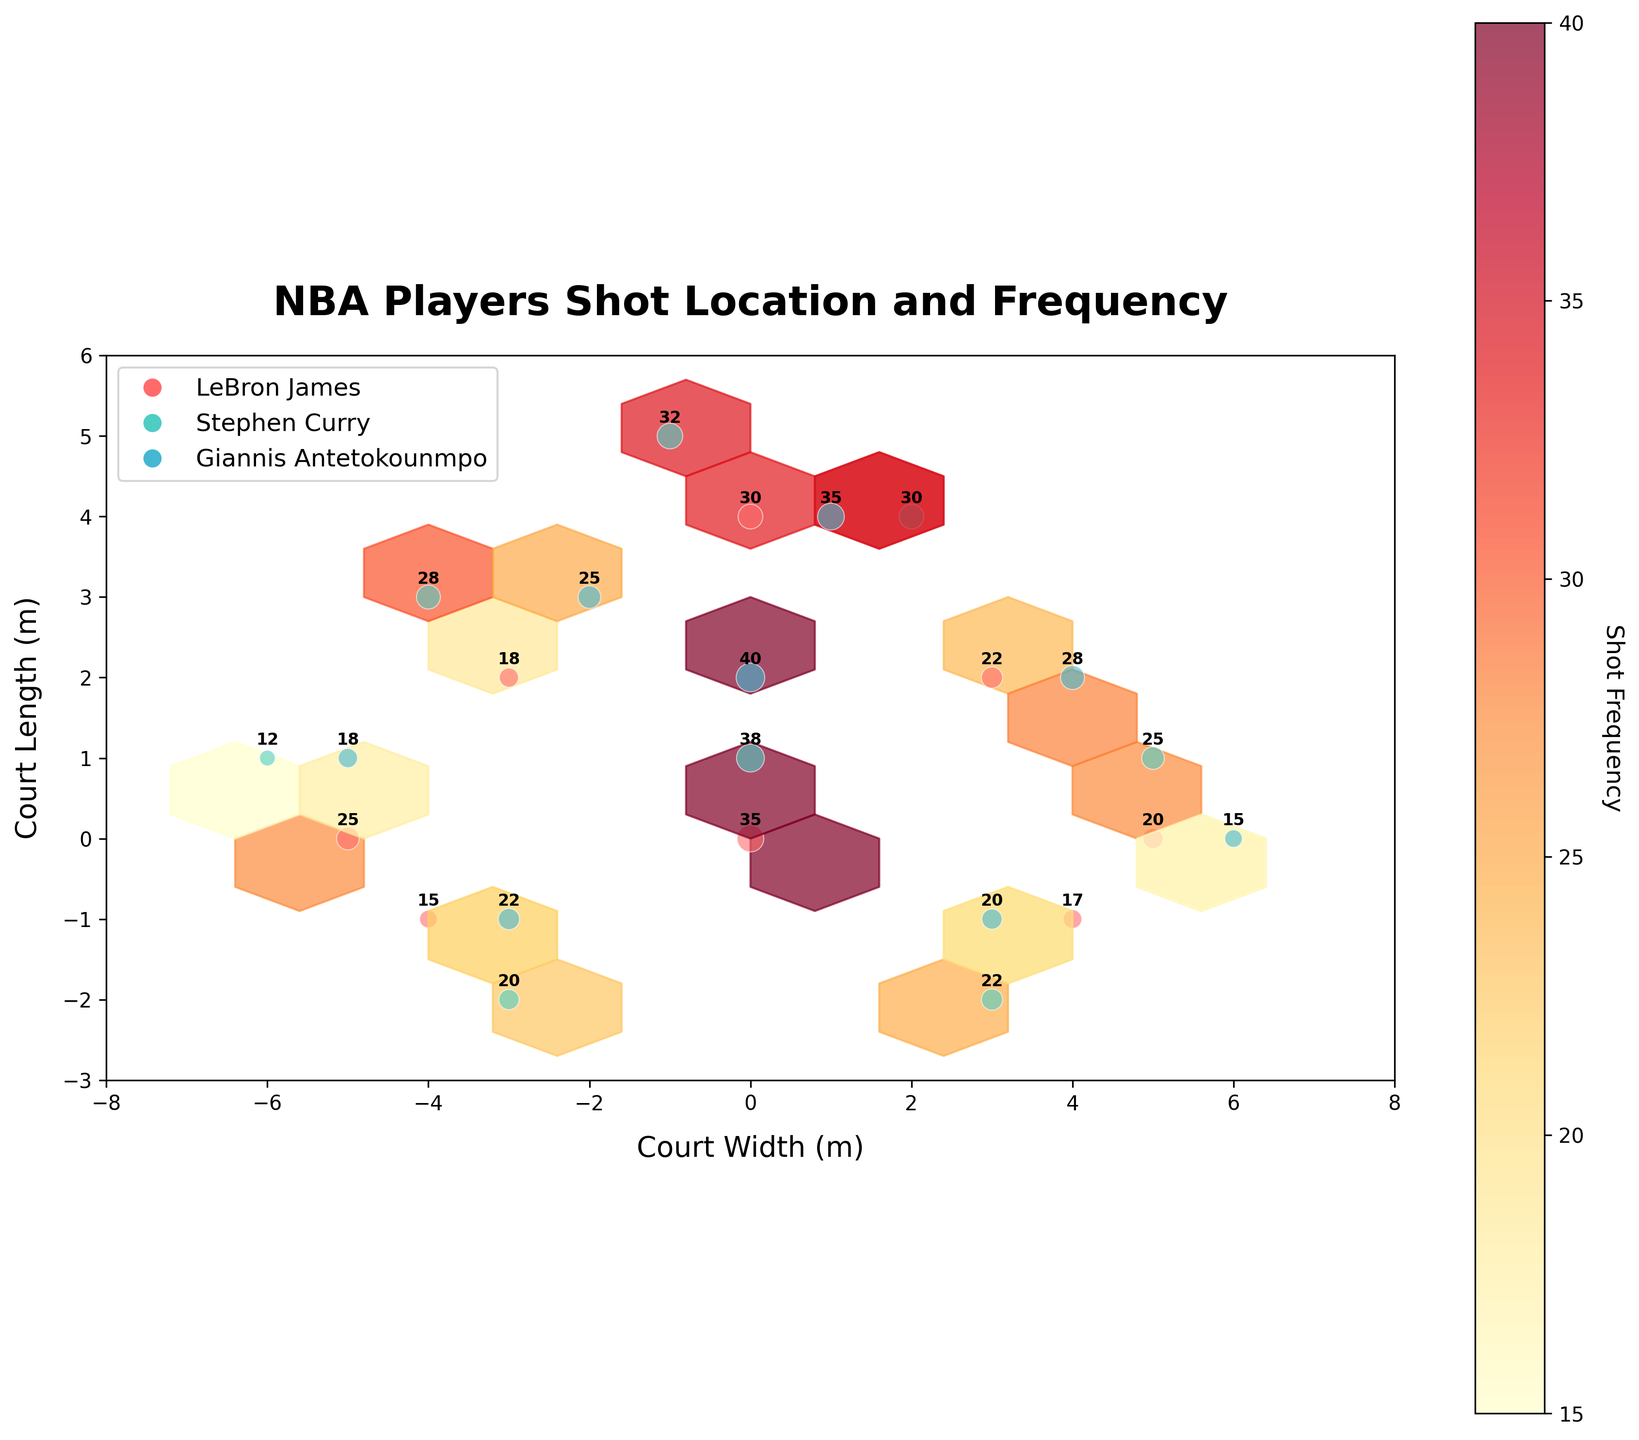What is the title of the figure? The title is usually located at the top of the figure and is meant to provide a succinct description of what the plot is about. For this figure, the title is a concise explanation of the plot's content.
Answer: NBA Players Shot Location and Frequency Which player has the highest shot frequency within the hexbin plot? To find out which player has the highest shot frequency, look at the player with the highest annotated frequency number.
Answer: Giannis Antetokounmpo Where on the court does LeBron James take the most shots? To determine the location where LeBron James takes the most shots, find the hexbin with the highest shot frequency value marked specifically for LeBron James.
Answer: Center of the court (0,0) How does Stephen Curry's shot distribution compare to Giannis Antetokounmpo's in terms of hot zones (areas with high shot frequency)? To compare Stephen Curry and Giannis Antetokounmpo's shot distributions, identify and compare the hexagons with the highest frequencies for each player. Stephen Curry's hot zones are densely distributed around (-1, 5), (2, 4), and Giannis Antetokounmpo has prominent hot zones around (1, 4) and (0, 2).
Answer: Stephen Curry has more hot zones spread out, but Giannis Antetokounmpo has concentrated hot zones Are there any significant cold spots (areas with low shot frequency) common to all players? To find common cold spots, look for areas where there are fewer or no shots taken by any of the players. These areas will have lower or no frequency annotations.
Answer: The area at (-6, 1) and (6, 0) What is the combined shot frequency of LeBron James at the coordinates (-5,0) and (5,0)? Add the shot frequencies of LeBron James at the specified coordinates. For (-5,0), it's 25, and for (5,0), it's 20. Thus, the combined shot frequency is 25 + 20.
Answer: 45 Which player takes more shots from the left side of the court? To determine which player takes more shots from the left side, sum the frequencies of shots taken by each player in negative x-coordinates and compare them.
Answer: LeBron James What is the color used to represent Stephen Curry's shots in the plot? Each player has a unique color representing their shots in the plot. To find Stephen Curry's color, refer to the legend associated with the plot.
Answer: A shade of teal Which player has the highest shot frequency in the center of the court (0,0)? To determine this, look at the shot frequency value annotated at the center of the court for each player. The highest number indicates the player with the most shots taken at that position.
Answer: LeBron James 